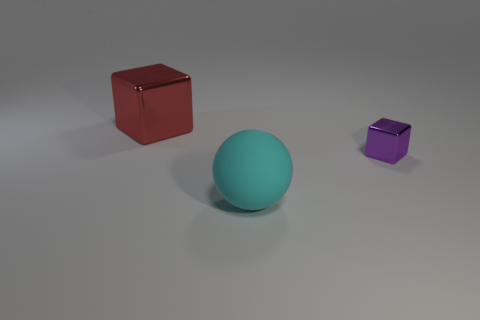Is there anything else that has the same size as the purple metallic thing?
Your answer should be very brief. No. The shiny thing that is the same size as the sphere is what color?
Give a very brief answer. Red. How many cylinders are large red metallic objects or big rubber objects?
Your answer should be compact. 0. How many cyan things are there?
Your answer should be very brief. 1. Do the purple shiny object and the big object that is behind the cyan matte object have the same shape?
Ensure brevity in your answer.  Yes. How many things are purple shiny objects or big matte blocks?
Provide a short and direct response. 1. The big object that is left of the big thing that is on the right side of the red metal block is what shape?
Offer a very short reply. Cube. There is a large thing on the left side of the rubber sphere; does it have the same shape as the tiny purple shiny thing?
Your answer should be very brief. Yes. What is the size of the purple object that is made of the same material as the large red thing?
Keep it short and to the point. Small. What number of things are big things right of the red block or metallic blocks on the left side of the cyan matte object?
Make the answer very short. 2. 